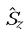<formula> <loc_0><loc_0><loc_500><loc_500>\hat { S } _ { z }</formula> 